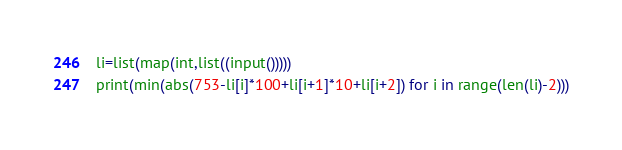<code> <loc_0><loc_0><loc_500><loc_500><_Python_>li=list(map(int,list((input()))))
print(min(abs(753-li[i]*100+li[i+1]*10+li[i+2]) for i in range(len(li)-2)))
</code> 